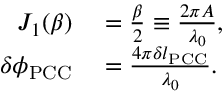Convert formula to latex. <formula><loc_0><loc_0><loc_500><loc_500>\begin{array} { r l } { J _ { 1 } ( \beta ) } & = \frac { \beta } { 2 } \equiv \frac { 2 \pi A } { \lambda _ { 0 } } , } \\ { \delta \phi _ { P C C } } & = \frac { 4 \pi \delta l _ { P C C } } { \lambda _ { 0 } } . } \end{array}</formula> 